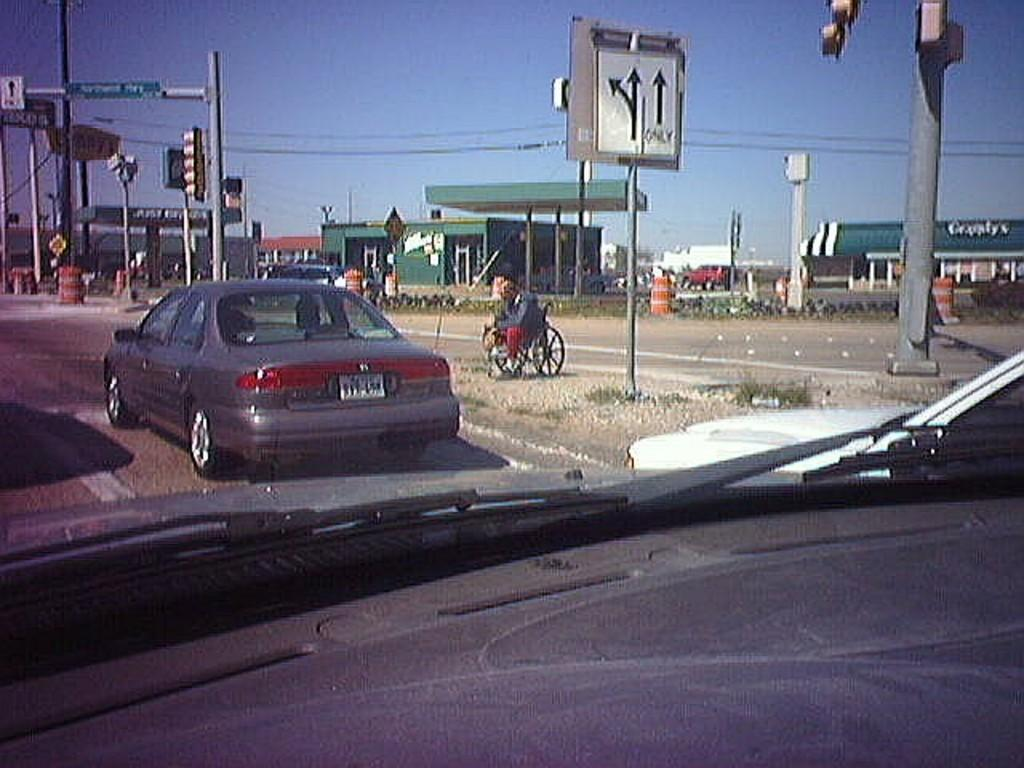What is the perspective of the image? The image is taken from a car mirror. What types of objects can be seen in the image? There are vehicles, houses, poles with signal lights, and wires visible in the image. Can you describe the infrastructure in the image? The image shows poles with signal lights, which are part of the traffic infrastructure. What type of furniture is visible in the image? There is no furniture present in the image. What territory is being claimed by the vehicles in the image? The image does not depict any territorial claims; it simply shows vehicles, houses, poles with signal lights, and wires. 